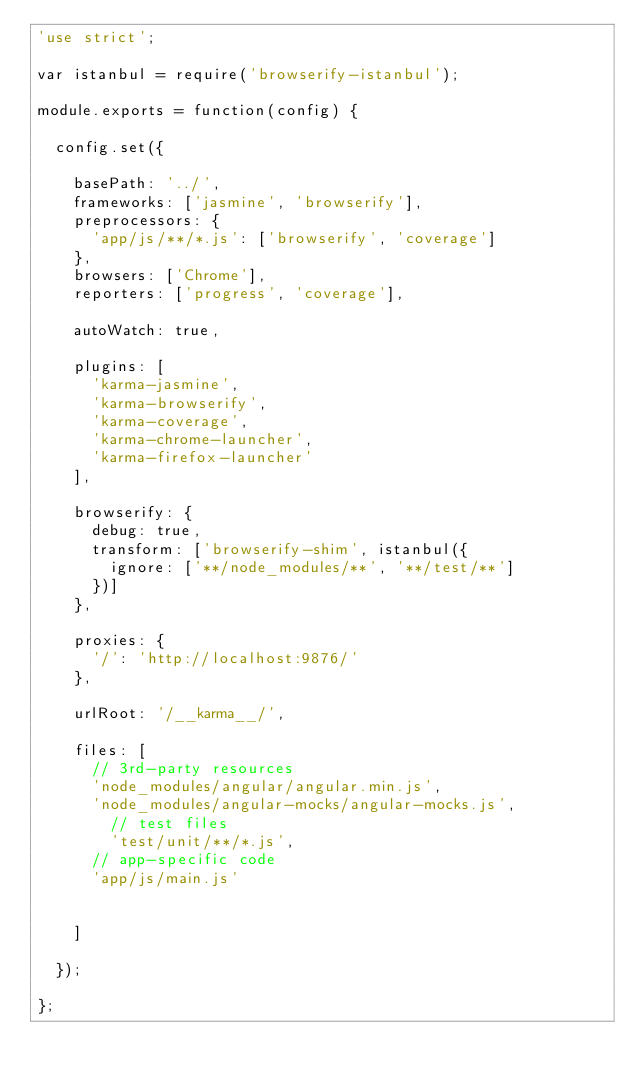<code> <loc_0><loc_0><loc_500><loc_500><_JavaScript_>'use strict';

var istanbul = require('browserify-istanbul');

module.exports = function(config) {

  config.set({

    basePath: '../',
    frameworks: ['jasmine', 'browserify'],
    preprocessors: {
      'app/js/**/*.js': ['browserify', 'coverage']
    },
    browsers: ['Chrome'],
    reporters: ['progress', 'coverage'],

    autoWatch: true,

    plugins: [
      'karma-jasmine',
      'karma-browserify',
      'karma-coverage',
      'karma-chrome-launcher',
      'karma-firefox-launcher'
    ],

    browserify: {
      debug: true,
      transform: ['browserify-shim', istanbul({
        ignore: ['**/node_modules/**', '**/test/**']
      })]
    },

    proxies: {
      '/': 'http://localhost:9876/'
    },

    urlRoot: '/__karma__/',

    files: [
      // 3rd-party resources
      'node_modules/angular/angular.min.js',
      'node_modules/angular-mocks/angular-mocks.js',
        // test files
        'test/unit/**/*.js',
      // app-specific code
      'app/js/main.js'


    ]

  });

};</code> 